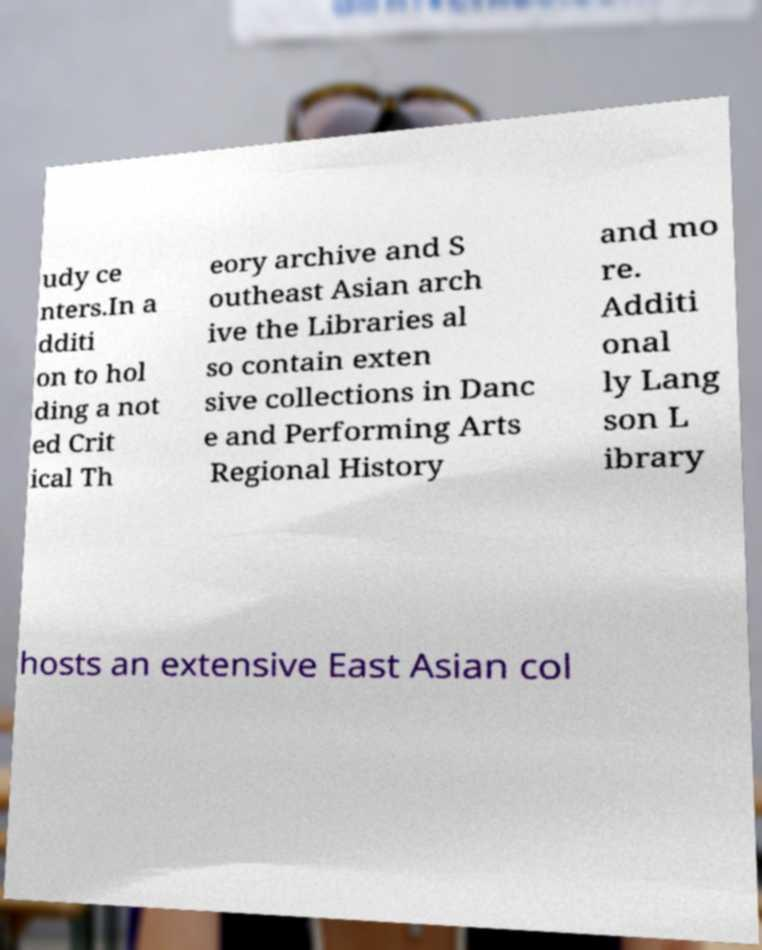Could you assist in decoding the text presented in this image and type it out clearly? udy ce nters.In a dditi on to hol ding a not ed Crit ical Th eory archive and S outheast Asian arch ive the Libraries al so contain exten sive collections in Danc e and Performing Arts Regional History and mo re. Additi onal ly Lang son L ibrary hosts an extensive East Asian col 